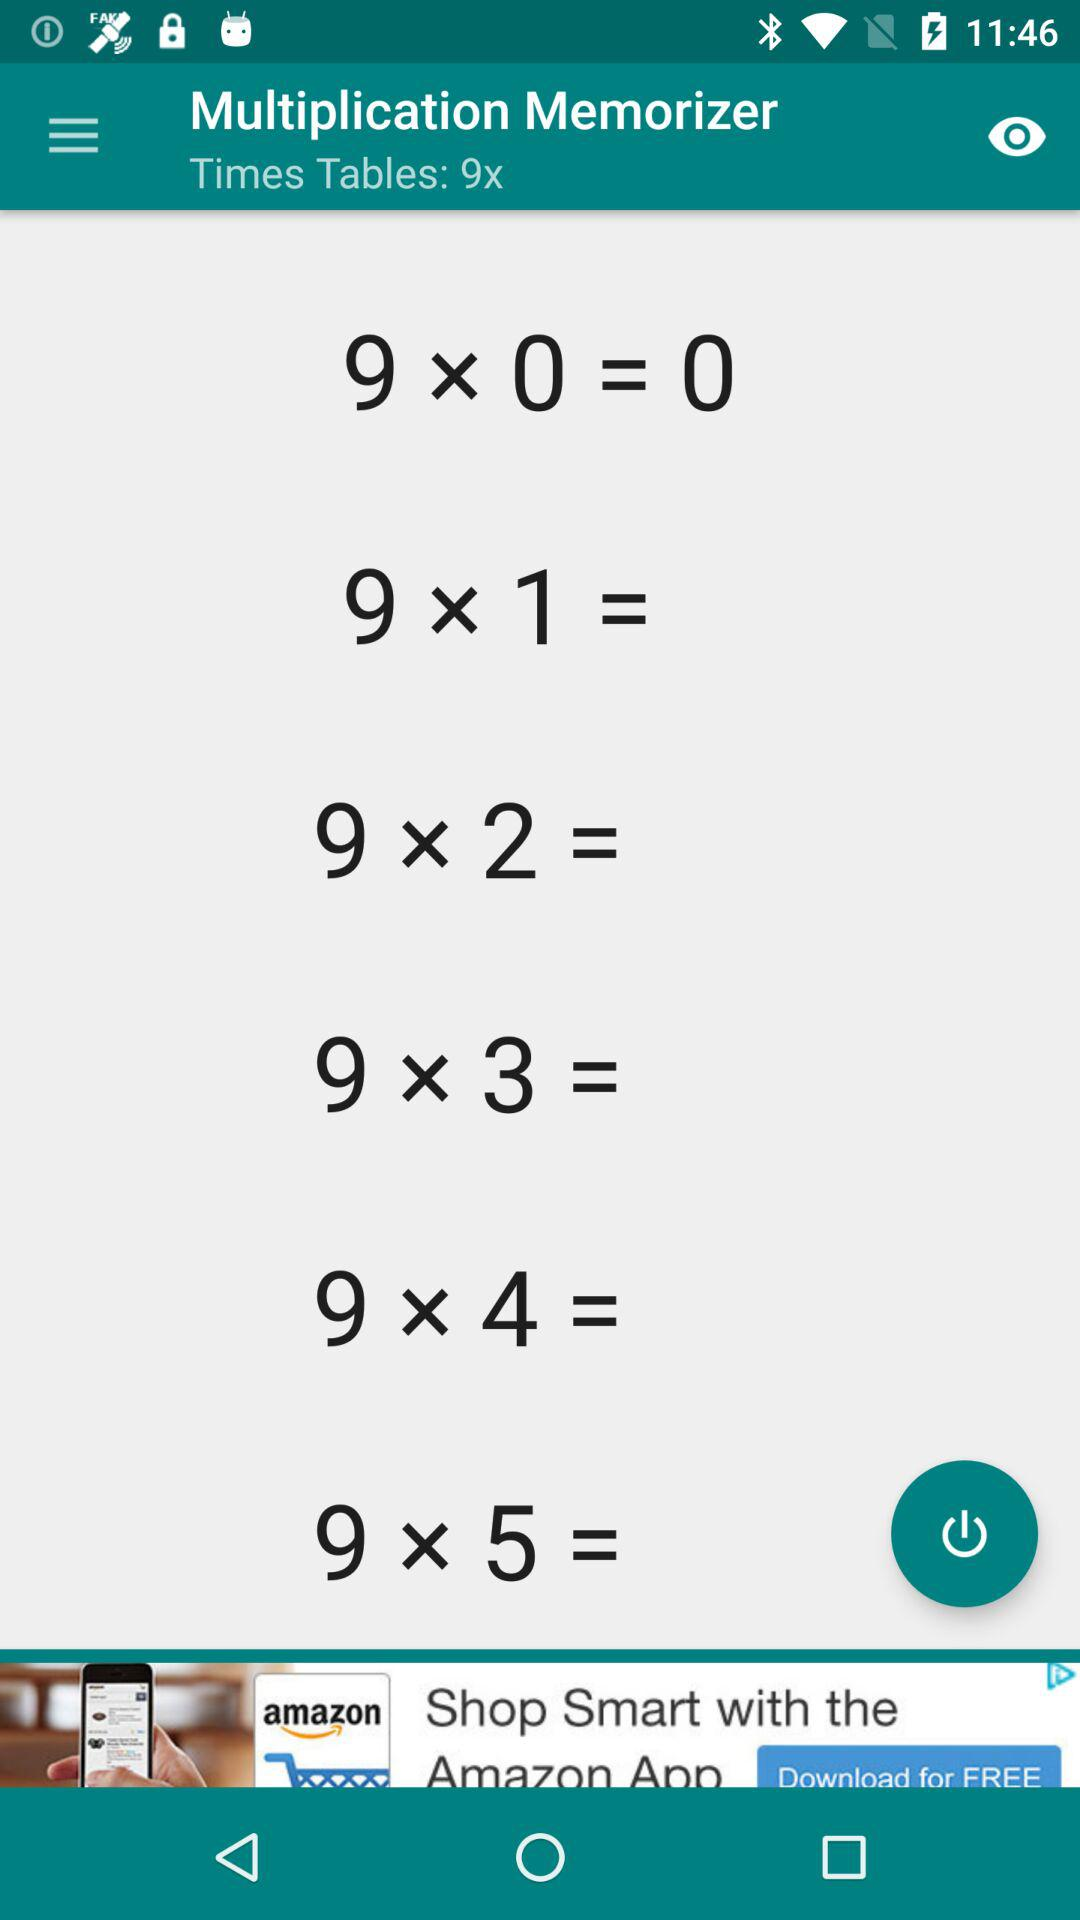What is the app name? The app name is "Multiplication Memorizer". 